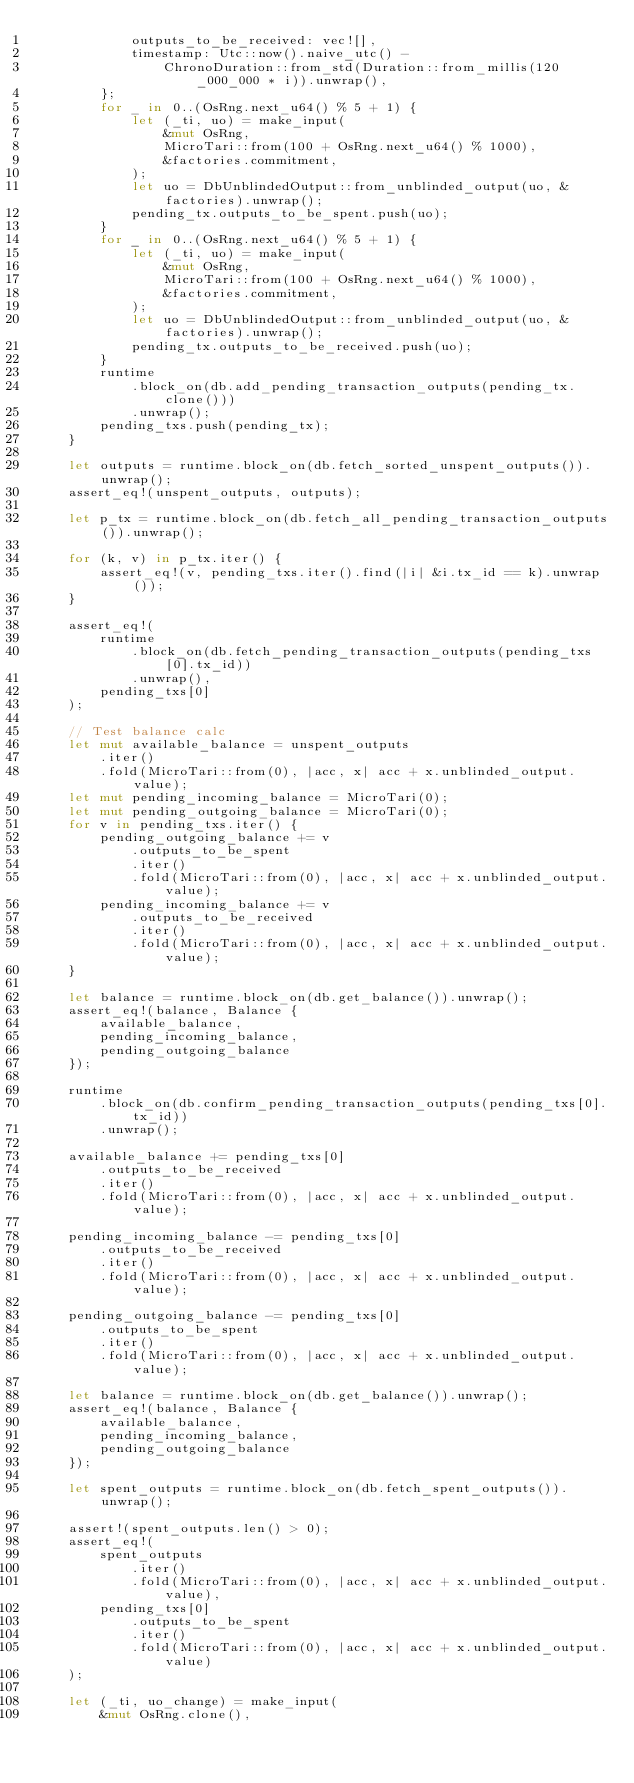Convert code to text. <code><loc_0><loc_0><loc_500><loc_500><_Rust_>            outputs_to_be_received: vec![],
            timestamp: Utc::now().naive_utc() -
                ChronoDuration::from_std(Duration::from_millis(120_000_000 * i)).unwrap(),
        };
        for _ in 0..(OsRng.next_u64() % 5 + 1) {
            let (_ti, uo) = make_input(
                &mut OsRng,
                MicroTari::from(100 + OsRng.next_u64() % 1000),
                &factories.commitment,
            );
            let uo = DbUnblindedOutput::from_unblinded_output(uo, &factories).unwrap();
            pending_tx.outputs_to_be_spent.push(uo);
        }
        for _ in 0..(OsRng.next_u64() % 5 + 1) {
            let (_ti, uo) = make_input(
                &mut OsRng,
                MicroTari::from(100 + OsRng.next_u64() % 1000),
                &factories.commitment,
            );
            let uo = DbUnblindedOutput::from_unblinded_output(uo, &factories).unwrap();
            pending_tx.outputs_to_be_received.push(uo);
        }
        runtime
            .block_on(db.add_pending_transaction_outputs(pending_tx.clone()))
            .unwrap();
        pending_txs.push(pending_tx);
    }

    let outputs = runtime.block_on(db.fetch_sorted_unspent_outputs()).unwrap();
    assert_eq!(unspent_outputs, outputs);

    let p_tx = runtime.block_on(db.fetch_all_pending_transaction_outputs()).unwrap();

    for (k, v) in p_tx.iter() {
        assert_eq!(v, pending_txs.iter().find(|i| &i.tx_id == k).unwrap());
    }

    assert_eq!(
        runtime
            .block_on(db.fetch_pending_transaction_outputs(pending_txs[0].tx_id))
            .unwrap(),
        pending_txs[0]
    );

    // Test balance calc
    let mut available_balance = unspent_outputs
        .iter()
        .fold(MicroTari::from(0), |acc, x| acc + x.unblinded_output.value);
    let mut pending_incoming_balance = MicroTari(0);
    let mut pending_outgoing_balance = MicroTari(0);
    for v in pending_txs.iter() {
        pending_outgoing_balance += v
            .outputs_to_be_spent
            .iter()
            .fold(MicroTari::from(0), |acc, x| acc + x.unblinded_output.value);
        pending_incoming_balance += v
            .outputs_to_be_received
            .iter()
            .fold(MicroTari::from(0), |acc, x| acc + x.unblinded_output.value);
    }

    let balance = runtime.block_on(db.get_balance()).unwrap();
    assert_eq!(balance, Balance {
        available_balance,
        pending_incoming_balance,
        pending_outgoing_balance
    });

    runtime
        .block_on(db.confirm_pending_transaction_outputs(pending_txs[0].tx_id))
        .unwrap();

    available_balance += pending_txs[0]
        .outputs_to_be_received
        .iter()
        .fold(MicroTari::from(0), |acc, x| acc + x.unblinded_output.value);

    pending_incoming_balance -= pending_txs[0]
        .outputs_to_be_received
        .iter()
        .fold(MicroTari::from(0), |acc, x| acc + x.unblinded_output.value);

    pending_outgoing_balance -= pending_txs[0]
        .outputs_to_be_spent
        .iter()
        .fold(MicroTari::from(0), |acc, x| acc + x.unblinded_output.value);

    let balance = runtime.block_on(db.get_balance()).unwrap();
    assert_eq!(balance, Balance {
        available_balance,
        pending_incoming_balance,
        pending_outgoing_balance
    });

    let spent_outputs = runtime.block_on(db.fetch_spent_outputs()).unwrap();

    assert!(spent_outputs.len() > 0);
    assert_eq!(
        spent_outputs
            .iter()
            .fold(MicroTari::from(0), |acc, x| acc + x.unblinded_output.value),
        pending_txs[0]
            .outputs_to_be_spent
            .iter()
            .fold(MicroTari::from(0), |acc, x| acc + x.unblinded_output.value)
    );

    let (_ti, uo_change) = make_input(
        &mut OsRng.clone(),</code> 